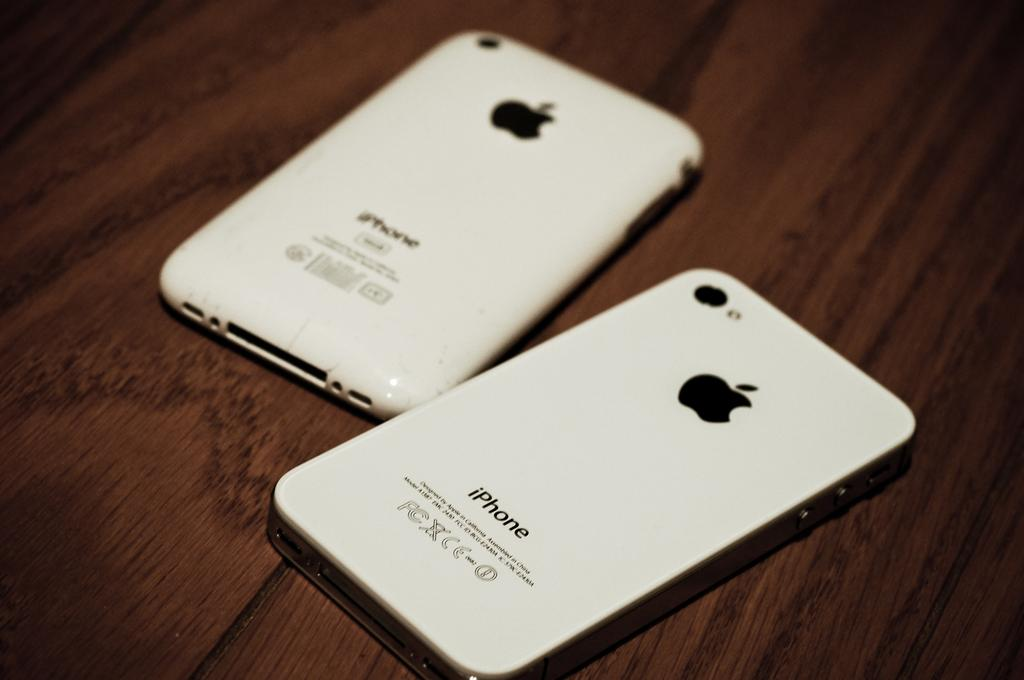<image>
Relay a brief, clear account of the picture shown. Two iphones are flipped upside down on a wooden table. 